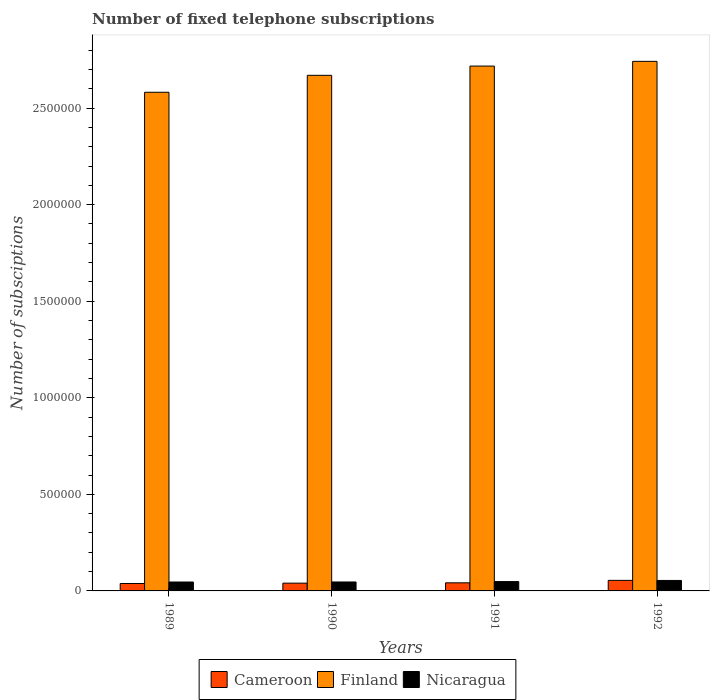How many groups of bars are there?
Offer a very short reply. 4. Are the number of bars on each tick of the X-axis equal?
Offer a terse response. Yes. How many bars are there on the 1st tick from the left?
Provide a short and direct response. 3. What is the number of fixed telephone subscriptions in Finland in 1992?
Give a very brief answer. 2.74e+06. Across all years, what is the maximum number of fixed telephone subscriptions in Finland?
Provide a succinct answer. 2.74e+06. Across all years, what is the minimum number of fixed telephone subscriptions in Nicaragua?
Provide a short and direct response. 4.62e+04. In which year was the number of fixed telephone subscriptions in Nicaragua minimum?
Make the answer very short. 1989. What is the total number of fixed telephone subscriptions in Cameroon in the graph?
Make the answer very short. 1.75e+05. What is the difference between the number of fixed telephone subscriptions in Finland in 1990 and that in 1992?
Your answer should be very brief. -7.23e+04. What is the difference between the number of fixed telephone subscriptions in Cameroon in 1992 and the number of fixed telephone subscriptions in Nicaragua in 1990?
Ensure brevity in your answer.  8344. What is the average number of fixed telephone subscriptions in Nicaragua per year?
Provide a succinct answer. 4.88e+04. In the year 1989, what is the difference between the number of fixed telephone subscriptions in Finland and number of fixed telephone subscriptions in Cameroon?
Ensure brevity in your answer.  2.54e+06. In how many years, is the number of fixed telephone subscriptions in Finland greater than 2100000?
Make the answer very short. 4. What is the ratio of the number of fixed telephone subscriptions in Finland in 1989 to that in 1992?
Ensure brevity in your answer.  0.94. What is the difference between the highest and the second highest number of fixed telephone subscriptions in Finland?
Give a very brief answer. 2.44e+04. What is the difference between the highest and the lowest number of fixed telephone subscriptions in Finland?
Your response must be concise. 1.60e+05. In how many years, is the number of fixed telephone subscriptions in Cameroon greater than the average number of fixed telephone subscriptions in Cameroon taken over all years?
Ensure brevity in your answer.  1. What does the 1st bar from the left in 1992 represents?
Give a very brief answer. Cameroon. What does the 1st bar from the right in 1990 represents?
Provide a succinct answer. Nicaragua. Is it the case that in every year, the sum of the number of fixed telephone subscriptions in Cameroon and number of fixed telephone subscriptions in Nicaragua is greater than the number of fixed telephone subscriptions in Finland?
Give a very brief answer. No. How many bars are there?
Keep it short and to the point. 12. What is the difference between two consecutive major ticks on the Y-axis?
Your answer should be compact. 5.00e+05. Are the values on the major ticks of Y-axis written in scientific E-notation?
Make the answer very short. No. Does the graph contain grids?
Provide a succinct answer. No. How are the legend labels stacked?
Provide a short and direct response. Horizontal. What is the title of the graph?
Give a very brief answer. Number of fixed telephone subscriptions. Does "Uruguay" appear as one of the legend labels in the graph?
Provide a short and direct response. No. What is the label or title of the Y-axis?
Ensure brevity in your answer.  Number of subsciptions. What is the Number of subsciptions in Cameroon in 1989?
Offer a very short reply. 3.85e+04. What is the Number of subsciptions in Finland in 1989?
Your response must be concise. 2.58e+06. What is the Number of subsciptions of Nicaragua in 1989?
Your answer should be very brief. 4.62e+04. What is the Number of subsciptions of Cameroon in 1990?
Keep it short and to the point. 4.02e+04. What is the Number of subsciptions in Finland in 1990?
Make the answer very short. 2.67e+06. What is the Number of subsciptions in Nicaragua in 1990?
Your answer should be very brief. 4.63e+04. What is the Number of subsciptions of Cameroon in 1991?
Offer a very short reply. 4.19e+04. What is the Number of subsciptions of Finland in 1991?
Provide a short and direct response. 2.72e+06. What is the Number of subsciptions of Nicaragua in 1991?
Your answer should be compact. 4.83e+04. What is the Number of subsciptions of Cameroon in 1992?
Offer a terse response. 5.47e+04. What is the Number of subsciptions of Finland in 1992?
Your answer should be compact. 2.74e+06. What is the Number of subsciptions of Nicaragua in 1992?
Provide a succinct answer. 5.43e+04. Across all years, what is the maximum Number of subsciptions of Cameroon?
Your answer should be compact. 5.47e+04. Across all years, what is the maximum Number of subsciptions of Finland?
Your answer should be very brief. 2.74e+06. Across all years, what is the maximum Number of subsciptions in Nicaragua?
Provide a succinct answer. 5.43e+04. Across all years, what is the minimum Number of subsciptions in Cameroon?
Make the answer very short. 3.85e+04. Across all years, what is the minimum Number of subsciptions of Finland?
Your answer should be very brief. 2.58e+06. Across all years, what is the minimum Number of subsciptions in Nicaragua?
Provide a short and direct response. 4.62e+04. What is the total Number of subsciptions of Cameroon in the graph?
Provide a succinct answer. 1.75e+05. What is the total Number of subsciptions in Finland in the graph?
Your answer should be compact. 1.07e+07. What is the total Number of subsciptions in Nicaragua in the graph?
Your response must be concise. 1.95e+05. What is the difference between the Number of subsciptions in Cameroon in 1989 and that in 1990?
Make the answer very short. -1750. What is the difference between the Number of subsciptions in Finland in 1989 and that in 1990?
Give a very brief answer. -8.77e+04. What is the difference between the Number of subsciptions in Nicaragua in 1989 and that in 1990?
Your response must be concise. -159. What is the difference between the Number of subsciptions of Cameroon in 1989 and that in 1991?
Offer a very short reply. -3465. What is the difference between the Number of subsciptions in Finland in 1989 and that in 1991?
Your response must be concise. -1.36e+05. What is the difference between the Number of subsciptions in Nicaragua in 1989 and that in 1991?
Give a very brief answer. -2136. What is the difference between the Number of subsciptions of Cameroon in 1989 and that in 1992?
Your response must be concise. -1.62e+04. What is the difference between the Number of subsciptions in Finland in 1989 and that in 1992?
Provide a short and direct response. -1.60e+05. What is the difference between the Number of subsciptions in Nicaragua in 1989 and that in 1992?
Provide a succinct answer. -8111. What is the difference between the Number of subsciptions in Cameroon in 1990 and that in 1991?
Keep it short and to the point. -1715. What is the difference between the Number of subsciptions of Finland in 1990 and that in 1991?
Provide a succinct answer. -4.79e+04. What is the difference between the Number of subsciptions of Nicaragua in 1990 and that in 1991?
Your answer should be compact. -1977. What is the difference between the Number of subsciptions in Cameroon in 1990 and that in 1992?
Give a very brief answer. -1.45e+04. What is the difference between the Number of subsciptions in Finland in 1990 and that in 1992?
Your answer should be very brief. -7.23e+04. What is the difference between the Number of subsciptions in Nicaragua in 1990 and that in 1992?
Your response must be concise. -7952. What is the difference between the Number of subsciptions of Cameroon in 1991 and that in 1992?
Keep it short and to the point. -1.27e+04. What is the difference between the Number of subsciptions of Finland in 1991 and that in 1992?
Make the answer very short. -2.44e+04. What is the difference between the Number of subsciptions in Nicaragua in 1991 and that in 1992?
Keep it short and to the point. -5975. What is the difference between the Number of subsciptions in Cameroon in 1989 and the Number of subsciptions in Finland in 1990?
Offer a very short reply. -2.63e+06. What is the difference between the Number of subsciptions in Cameroon in 1989 and the Number of subsciptions in Nicaragua in 1990?
Offer a very short reply. -7860. What is the difference between the Number of subsciptions of Finland in 1989 and the Number of subsciptions of Nicaragua in 1990?
Your response must be concise. 2.54e+06. What is the difference between the Number of subsciptions of Cameroon in 1989 and the Number of subsciptions of Finland in 1991?
Offer a terse response. -2.68e+06. What is the difference between the Number of subsciptions of Cameroon in 1989 and the Number of subsciptions of Nicaragua in 1991?
Make the answer very short. -9837. What is the difference between the Number of subsciptions of Finland in 1989 and the Number of subsciptions of Nicaragua in 1991?
Your response must be concise. 2.53e+06. What is the difference between the Number of subsciptions of Cameroon in 1989 and the Number of subsciptions of Finland in 1992?
Keep it short and to the point. -2.70e+06. What is the difference between the Number of subsciptions of Cameroon in 1989 and the Number of subsciptions of Nicaragua in 1992?
Give a very brief answer. -1.58e+04. What is the difference between the Number of subsciptions in Finland in 1989 and the Number of subsciptions in Nicaragua in 1992?
Your answer should be compact. 2.53e+06. What is the difference between the Number of subsciptions in Cameroon in 1990 and the Number of subsciptions in Finland in 1991?
Offer a very short reply. -2.68e+06. What is the difference between the Number of subsciptions in Cameroon in 1990 and the Number of subsciptions in Nicaragua in 1991?
Your answer should be compact. -8087. What is the difference between the Number of subsciptions of Finland in 1990 and the Number of subsciptions of Nicaragua in 1991?
Your response must be concise. 2.62e+06. What is the difference between the Number of subsciptions of Cameroon in 1990 and the Number of subsciptions of Finland in 1992?
Offer a very short reply. -2.70e+06. What is the difference between the Number of subsciptions of Cameroon in 1990 and the Number of subsciptions of Nicaragua in 1992?
Keep it short and to the point. -1.41e+04. What is the difference between the Number of subsciptions in Finland in 1990 and the Number of subsciptions in Nicaragua in 1992?
Offer a terse response. 2.62e+06. What is the difference between the Number of subsciptions in Cameroon in 1991 and the Number of subsciptions in Finland in 1992?
Keep it short and to the point. -2.70e+06. What is the difference between the Number of subsciptions of Cameroon in 1991 and the Number of subsciptions of Nicaragua in 1992?
Offer a very short reply. -1.23e+04. What is the difference between the Number of subsciptions of Finland in 1991 and the Number of subsciptions of Nicaragua in 1992?
Your answer should be compact. 2.66e+06. What is the average Number of subsciptions of Cameroon per year?
Keep it short and to the point. 4.38e+04. What is the average Number of subsciptions in Finland per year?
Provide a short and direct response. 2.68e+06. What is the average Number of subsciptions of Nicaragua per year?
Your response must be concise. 4.88e+04. In the year 1989, what is the difference between the Number of subsciptions in Cameroon and Number of subsciptions in Finland?
Offer a terse response. -2.54e+06. In the year 1989, what is the difference between the Number of subsciptions in Cameroon and Number of subsciptions in Nicaragua?
Your answer should be compact. -7701. In the year 1989, what is the difference between the Number of subsciptions in Finland and Number of subsciptions in Nicaragua?
Make the answer very short. 2.54e+06. In the year 1990, what is the difference between the Number of subsciptions of Cameroon and Number of subsciptions of Finland?
Your response must be concise. -2.63e+06. In the year 1990, what is the difference between the Number of subsciptions of Cameroon and Number of subsciptions of Nicaragua?
Offer a terse response. -6110. In the year 1990, what is the difference between the Number of subsciptions of Finland and Number of subsciptions of Nicaragua?
Ensure brevity in your answer.  2.62e+06. In the year 1991, what is the difference between the Number of subsciptions of Cameroon and Number of subsciptions of Finland?
Your answer should be very brief. -2.68e+06. In the year 1991, what is the difference between the Number of subsciptions of Cameroon and Number of subsciptions of Nicaragua?
Ensure brevity in your answer.  -6372. In the year 1991, what is the difference between the Number of subsciptions of Finland and Number of subsciptions of Nicaragua?
Make the answer very short. 2.67e+06. In the year 1992, what is the difference between the Number of subsciptions of Cameroon and Number of subsciptions of Finland?
Provide a short and direct response. -2.69e+06. In the year 1992, what is the difference between the Number of subsciptions of Cameroon and Number of subsciptions of Nicaragua?
Offer a very short reply. 392. In the year 1992, what is the difference between the Number of subsciptions of Finland and Number of subsciptions of Nicaragua?
Keep it short and to the point. 2.69e+06. What is the ratio of the Number of subsciptions of Cameroon in 1989 to that in 1990?
Keep it short and to the point. 0.96. What is the ratio of the Number of subsciptions of Finland in 1989 to that in 1990?
Provide a short and direct response. 0.97. What is the ratio of the Number of subsciptions of Cameroon in 1989 to that in 1991?
Offer a terse response. 0.92. What is the ratio of the Number of subsciptions of Finland in 1989 to that in 1991?
Provide a short and direct response. 0.95. What is the ratio of the Number of subsciptions in Nicaragua in 1989 to that in 1991?
Provide a short and direct response. 0.96. What is the ratio of the Number of subsciptions of Cameroon in 1989 to that in 1992?
Ensure brevity in your answer.  0.7. What is the ratio of the Number of subsciptions of Finland in 1989 to that in 1992?
Give a very brief answer. 0.94. What is the ratio of the Number of subsciptions in Nicaragua in 1989 to that in 1992?
Give a very brief answer. 0.85. What is the ratio of the Number of subsciptions in Cameroon in 1990 to that in 1991?
Ensure brevity in your answer.  0.96. What is the ratio of the Number of subsciptions of Finland in 1990 to that in 1991?
Provide a succinct answer. 0.98. What is the ratio of the Number of subsciptions of Nicaragua in 1990 to that in 1991?
Your response must be concise. 0.96. What is the ratio of the Number of subsciptions in Cameroon in 1990 to that in 1992?
Ensure brevity in your answer.  0.74. What is the ratio of the Number of subsciptions in Finland in 1990 to that in 1992?
Your response must be concise. 0.97. What is the ratio of the Number of subsciptions of Nicaragua in 1990 to that in 1992?
Make the answer very short. 0.85. What is the ratio of the Number of subsciptions of Cameroon in 1991 to that in 1992?
Your response must be concise. 0.77. What is the ratio of the Number of subsciptions of Nicaragua in 1991 to that in 1992?
Make the answer very short. 0.89. What is the difference between the highest and the second highest Number of subsciptions of Cameroon?
Make the answer very short. 1.27e+04. What is the difference between the highest and the second highest Number of subsciptions in Finland?
Give a very brief answer. 2.44e+04. What is the difference between the highest and the second highest Number of subsciptions in Nicaragua?
Offer a terse response. 5975. What is the difference between the highest and the lowest Number of subsciptions in Cameroon?
Offer a very short reply. 1.62e+04. What is the difference between the highest and the lowest Number of subsciptions of Finland?
Ensure brevity in your answer.  1.60e+05. What is the difference between the highest and the lowest Number of subsciptions of Nicaragua?
Ensure brevity in your answer.  8111. 